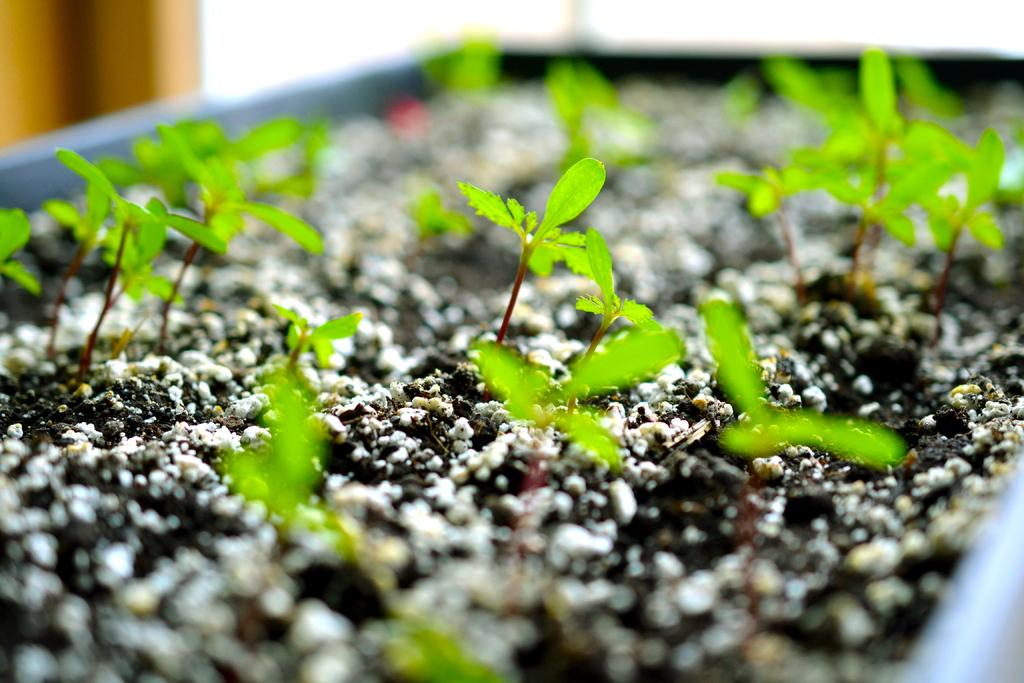What is the main object in the center of the image? There is a flower pot in the center of the image. What is growing inside the flower pot? There are seedlings in the flower pot. What discovery was made in the flower pot? There is no mention of a discovery in the image; it simply shows a flower pot with seedlings. What type of bed is visible in the image? There is no bed present in the image; it only features a flower pot with seedlings. 